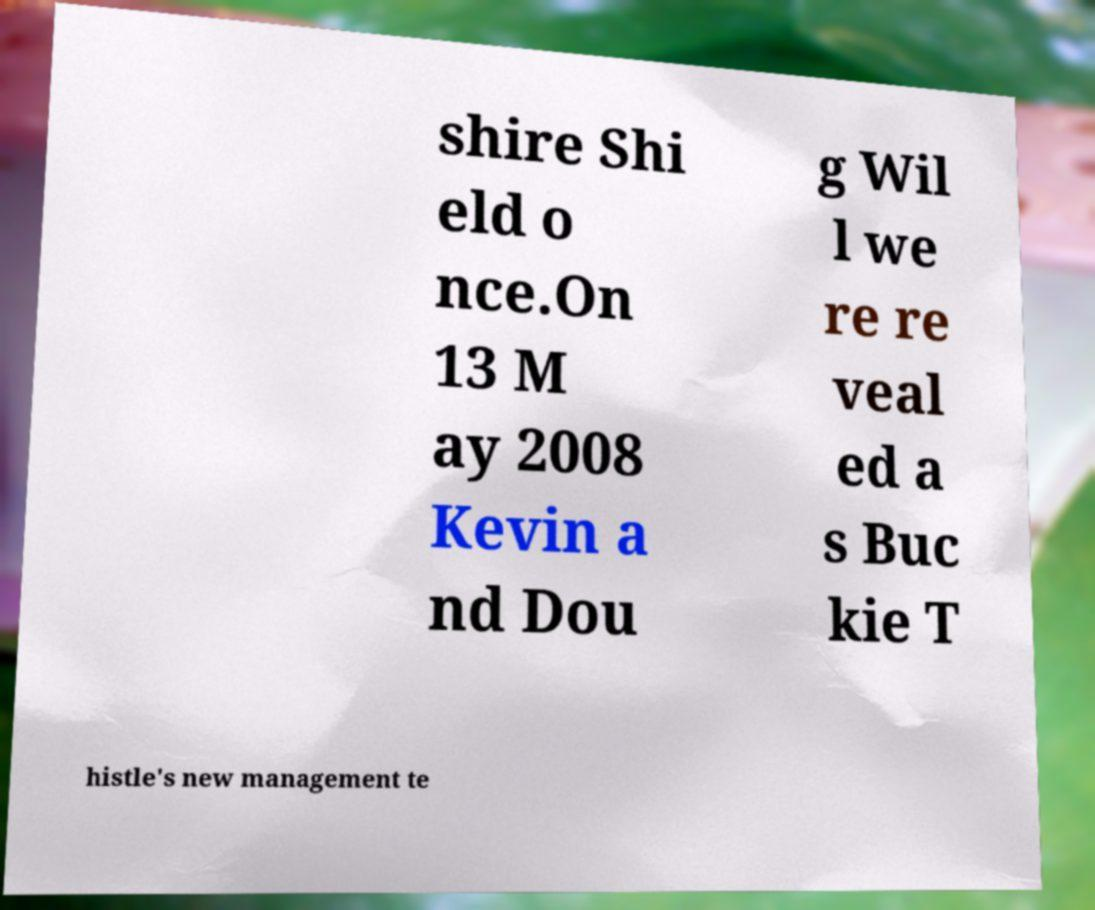Could you extract and type out the text from this image? shire Shi eld o nce.On 13 M ay 2008 Kevin a nd Dou g Wil l we re re veal ed a s Buc kie T histle's new management te 